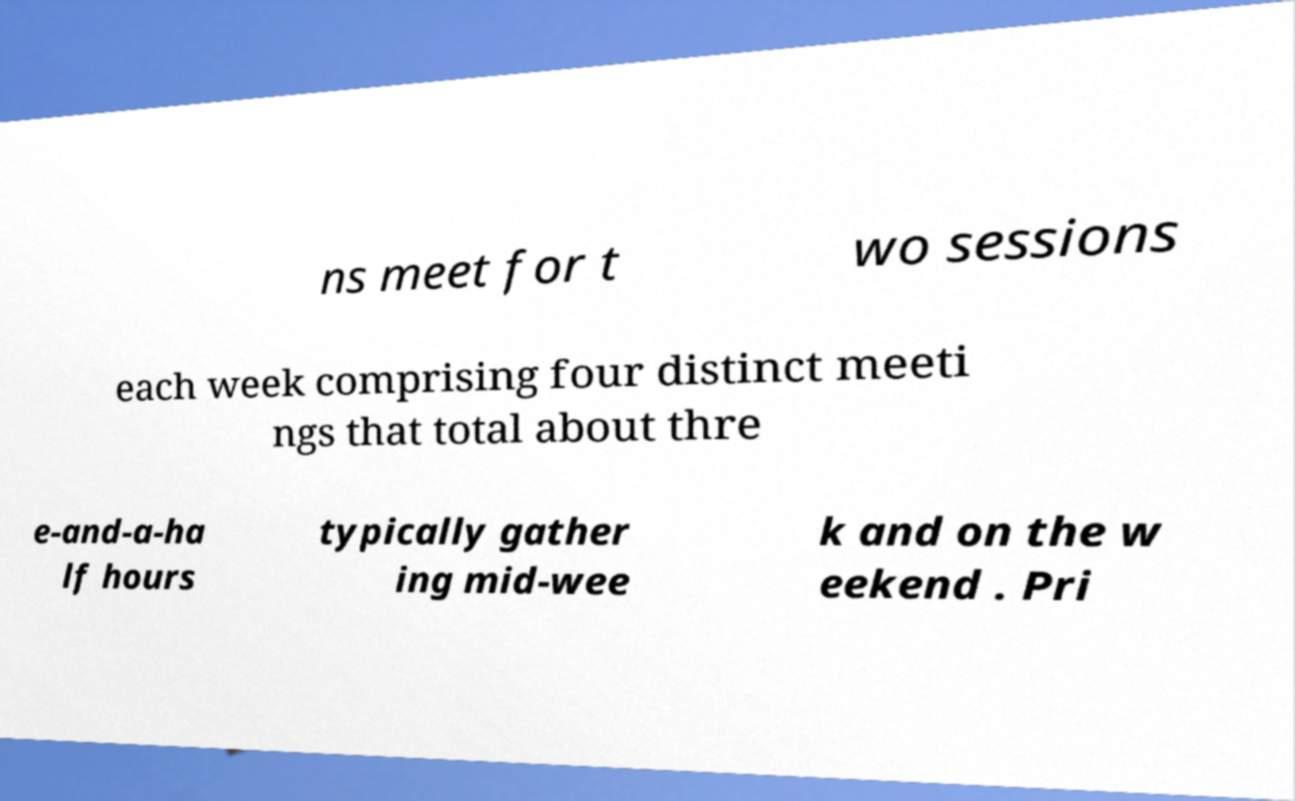Please identify and transcribe the text found in this image. ns meet for t wo sessions each week comprising four distinct meeti ngs that total about thre e-and-a-ha lf hours typically gather ing mid-wee k and on the w eekend . Pri 